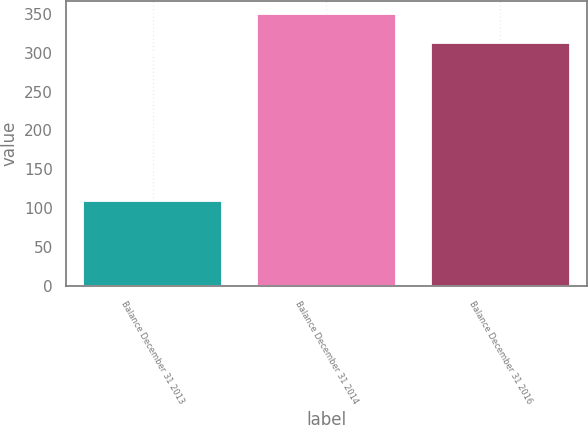<chart> <loc_0><loc_0><loc_500><loc_500><bar_chart><fcel>Balance December 31 2013<fcel>Balance December 31 2014<fcel>Balance December 31 2016<nl><fcel>110<fcel>349<fcel>312<nl></chart> 